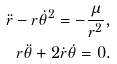<formula> <loc_0><loc_0><loc_500><loc_500>\ddot { r } - r \dot { \theta } ^ { 2 } = - \frac { \mu } { r ^ { 2 } } , \\ r \ddot { \theta } + 2 \dot { r } \dot { \theta } = 0 .</formula> 